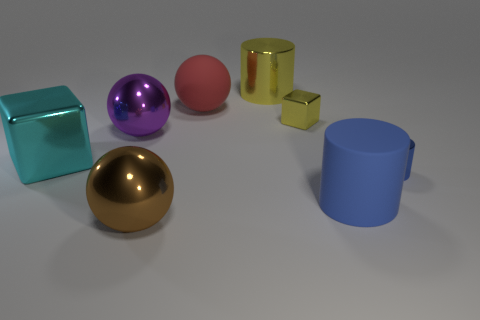Add 2 big purple balls. How many objects exist? 10 Subtract all blocks. How many objects are left? 6 Add 4 cyan things. How many cyan things are left? 5 Add 1 large green rubber spheres. How many large green rubber spheres exist? 1 Subtract 0 gray cubes. How many objects are left? 8 Subtract all yellow objects. Subtract all big metallic spheres. How many objects are left? 4 